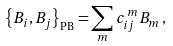<formula> <loc_0><loc_0><loc_500><loc_500>\left \{ B _ { i } , B _ { j } \right \} _ { \text {PB} } = \sum _ { m } c _ { i j } ^ { \, m } B _ { m } \, ,</formula> 